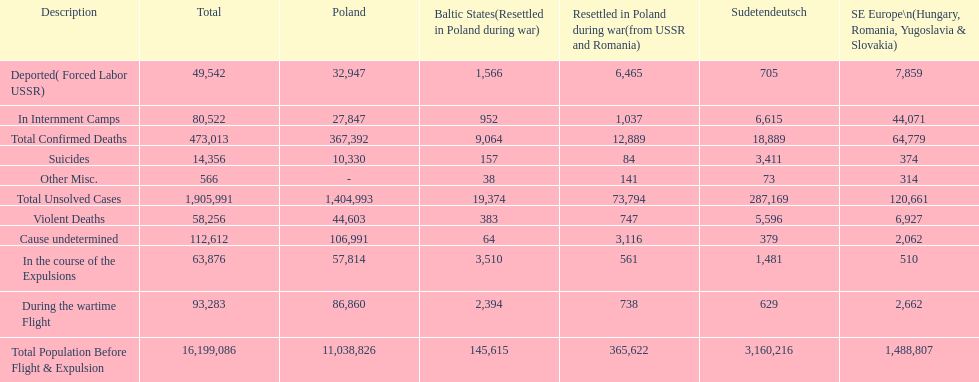Before expulsion, was the complete population larger in poland or sudetendeutsch? Poland. 